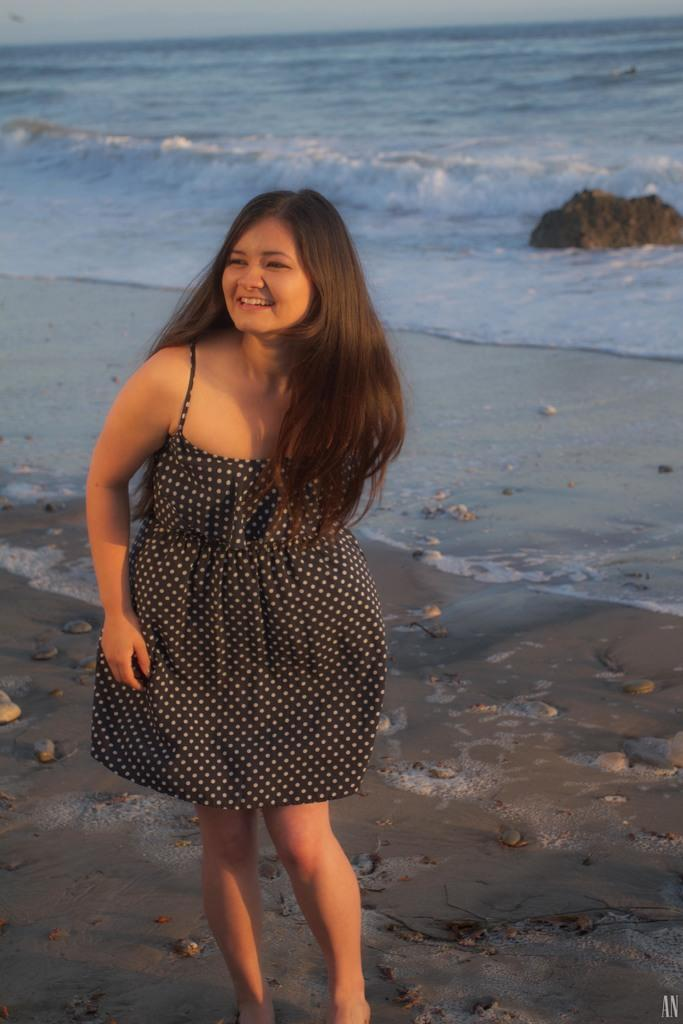Who is the main subject in the image? There is a girl in the image. What is the girl wearing? The girl is wearing a black dress. Where was the image taken? The image was taken near a beach. What can be seen at the bottom of the image? There is sand at the bottom of the image. What is visible in the background of the image? There are waves in the water and a rock in the background. How does the girl express regret in the image? There is no indication in the image that the girl is expressing regret. What type of disease can be seen in the image? There is no disease present in the image; it features a girl near a beach. 